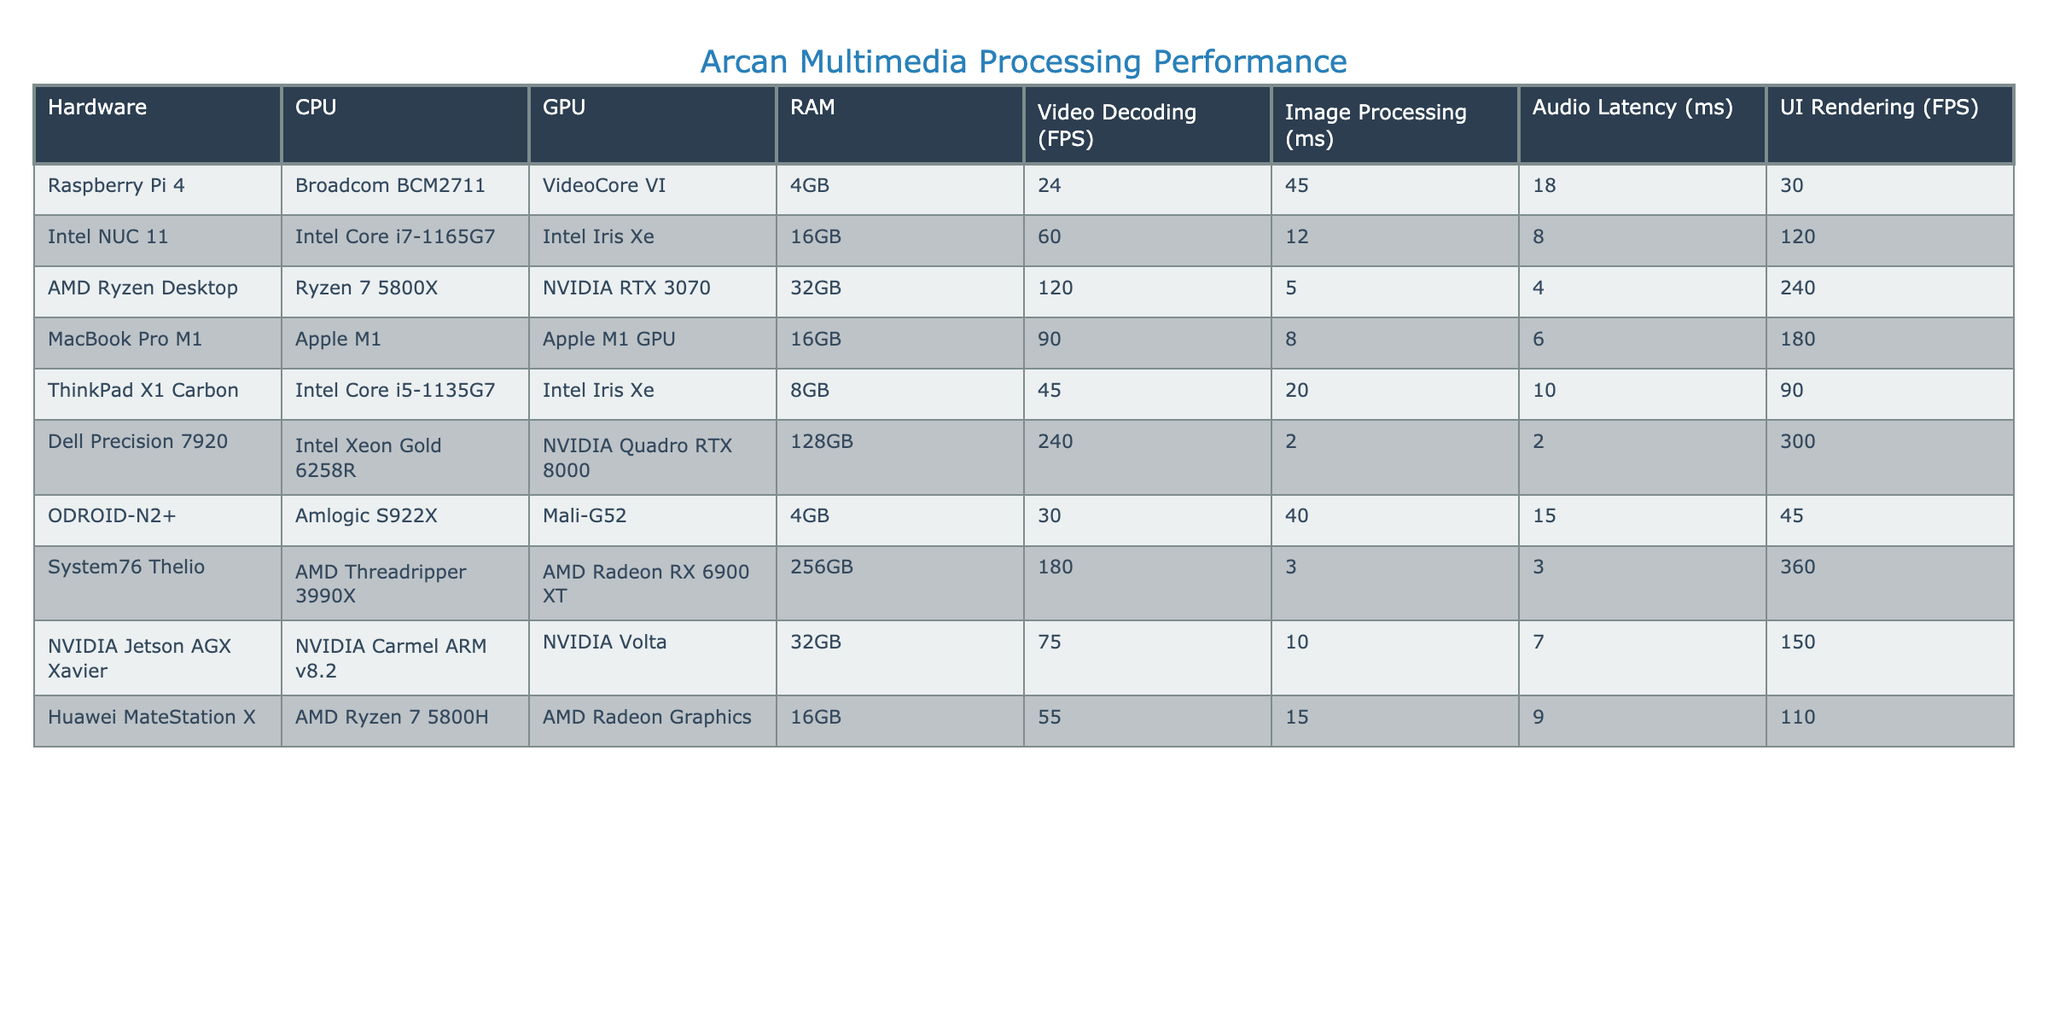What is the video decoding FPS for the AMD Ryzen Desktop? The table shows that the AMD Ryzen Desktop has a video decoding rate of 120 FPS.
Answer: 120 FPS Which hardware setup has the lowest image processing time? Looking at the "Image Processing (ms)" column, the Dell Precision 7920 has the lowest time of 2 ms.
Answer: 2 ms Is the audio latency for the Raspberry Pi 4 higher than that of the Intel NUC 11? The audio latency for Raspberry Pi 4 is 18 ms, while for Intel NUC 11 it is 8 ms. Since 18 ms is greater than 8 ms, the answer is yes.
Answer: Yes What is the average RAM across all hardware setups? First, total the RAM values: 4GB + 16GB + 32GB + 16GB + 8GB + 128GB + 4GB + 256GB + 32GB + 16GB = 256GB. There are 10 setups, so the average RAM is 256GB / 10 = 25.6GB.
Answer: 25.6GB Which hardware has the highest UI rendering FPS, and what is that value? Looking at the "UI Rendering (FPS)" column, the Dell Precision 7920 shows the highest value of 300 FPS.
Answer: 300 FPS Does the MacBook Pro M1 perform better in terms of video decoding FPS compared to the Huawei MateStation X? The MacBook Pro M1 has 90 FPS for video decoding, while the Huawei MateStation X has 55 FPS. Since 90 is greater than 55, the MacBook Pro M1 performs better.
Answer: Yes What is the sum of audio latencies for all devices? The audio latencies are 18 + 8 + 4 + 6 + 10 + 2 + 15 + 3 + 7 + 9 = 78 ms. Therefore, the total sum of audio latencies for all devices is 78 ms.
Answer: 78 ms Which two hardware setups have the closest UI rendering FPS, and what is that value? Comparing the "UI Rendering (FPS)" values, ODROID-N2+ has 45 FPS and the ThinkPad X1 Carbon has 90 FPS. The closest are the Huawei MateStation X (110 FPS) and the Intel NUC 11 (120 FPS) with a difference of 10 FPS.
Answer: 110 FPS and 120 FPS Is the performance (in terms of FPS for video decoding) of the Dell Precision 7920 more than twice that of the Raspberry Pi 4? The Dell Precision 7920 has 240 FPS, while the Raspberry Pi 4 has 24 FPS. Twice the video decoding rate of Raspberry Pi 4 is 48 FPS. Since 240 FPS is greater than 48 FPS, the answer is yes.
Answer: Yes 